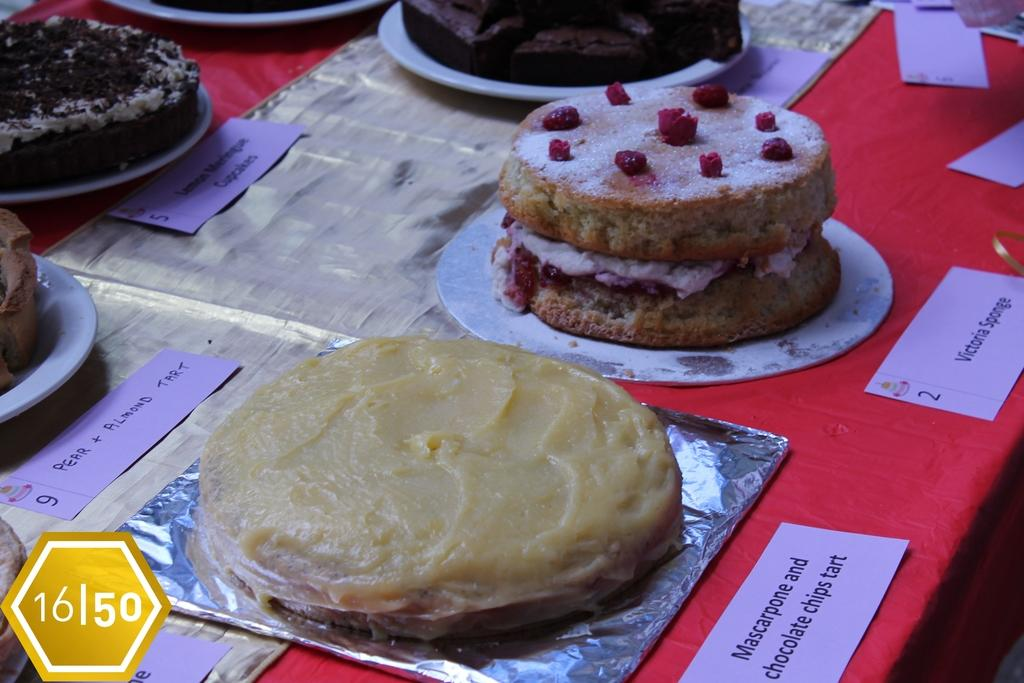What is the main piece of furniture in the image? There is a table in the image. What is covering the table? There is a red cloth on the table. What type of food can be seen on the red cloth? There are different types of cakes on the red cloth. How many ears can be seen on the cakes in the image? There are no ears present on the cakes in the image. 